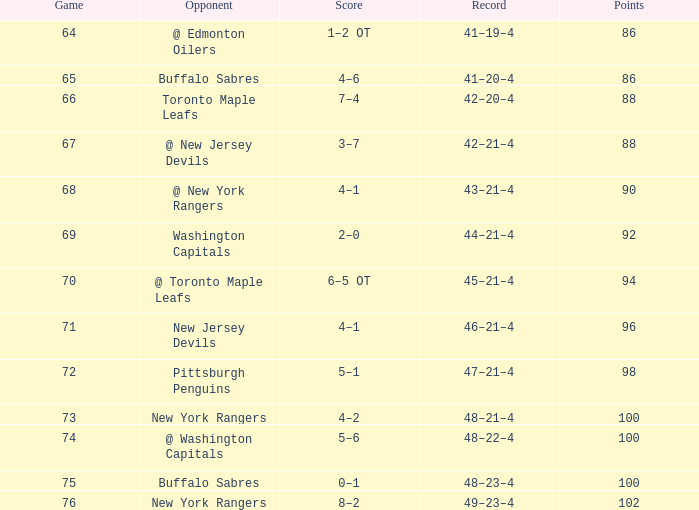In which score does the march surpass 15, points go beyond 96, game is under 76, and the opponent is @ washington capitals? 5–6. 